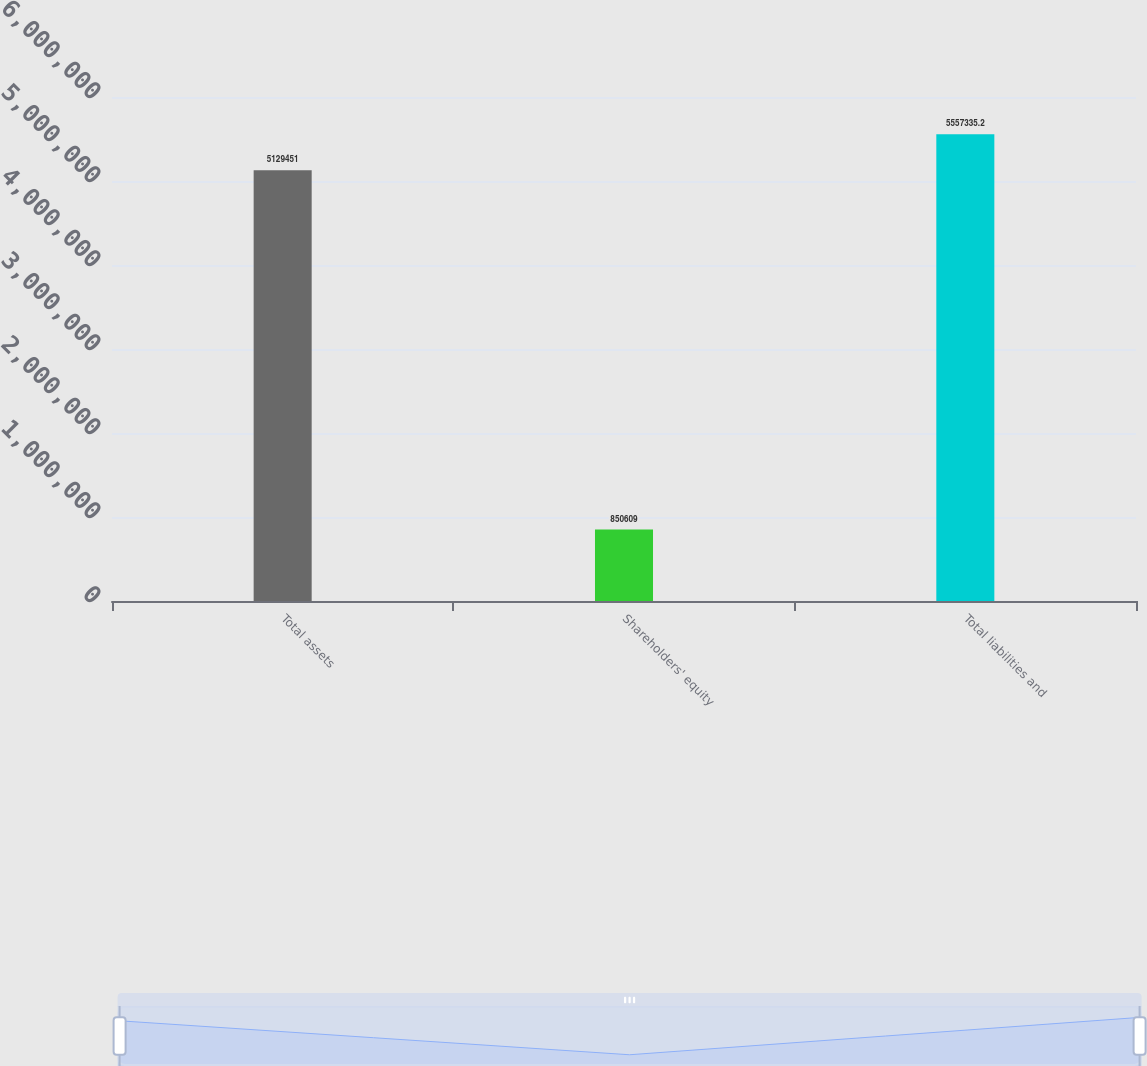Convert chart. <chart><loc_0><loc_0><loc_500><loc_500><bar_chart><fcel>Total assets<fcel>Shareholders' equity<fcel>Total liabilities and<nl><fcel>5.12945e+06<fcel>850609<fcel>5.55734e+06<nl></chart> 